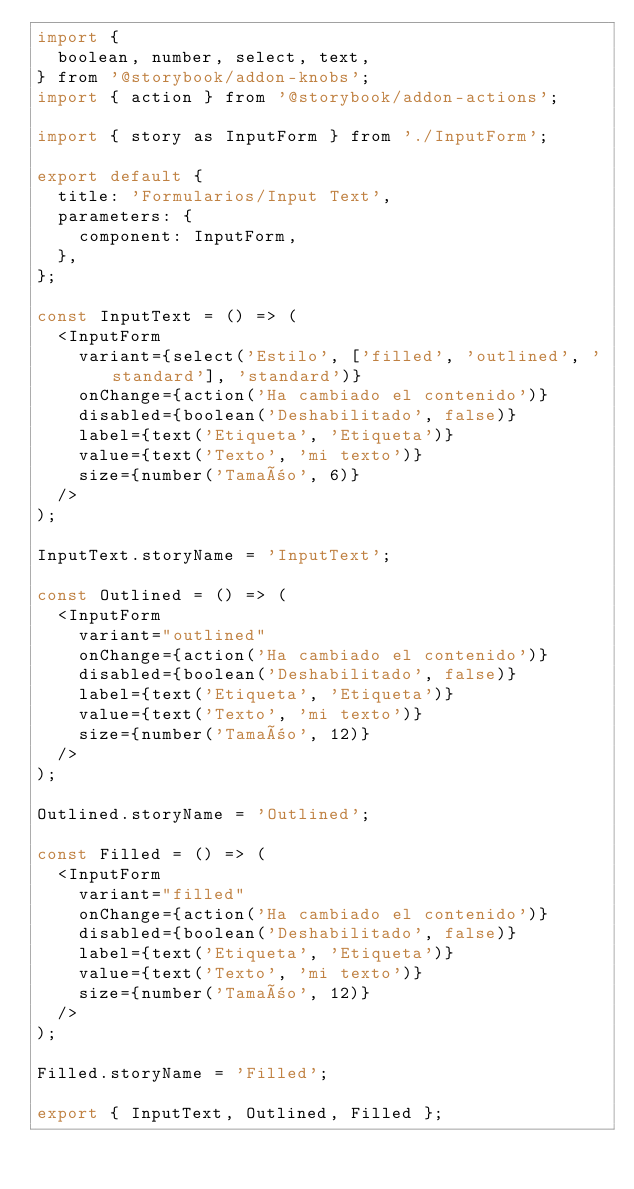Convert code to text. <code><loc_0><loc_0><loc_500><loc_500><_JavaScript_>import {
  boolean, number, select, text,
} from '@storybook/addon-knobs';
import { action } from '@storybook/addon-actions';

import { story as InputForm } from './InputForm';

export default {
  title: 'Formularios/Input Text',
  parameters: {
    component: InputForm,
  },
};

const InputText = () => (
  <InputForm
    variant={select('Estilo', ['filled', 'outlined', 'standard'], 'standard')}
    onChange={action('Ha cambiado el contenido')}
    disabled={boolean('Deshabilitado', false)}
    label={text('Etiqueta', 'Etiqueta')}
    value={text('Texto', 'mi texto')}
    size={number('Tamaño', 6)}
  />
);

InputText.storyName = 'InputText';

const Outlined = () => (
  <InputForm
    variant="outlined"
    onChange={action('Ha cambiado el contenido')}
    disabled={boolean('Deshabilitado', false)}
    label={text('Etiqueta', 'Etiqueta')}
    value={text('Texto', 'mi texto')}
    size={number('Tamaño', 12)}
  />
);

Outlined.storyName = 'Outlined';

const Filled = () => (
  <InputForm
    variant="filled"
    onChange={action('Ha cambiado el contenido')}
    disabled={boolean('Deshabilitado', false)}
    label={text('Etiqueta', 'Etiqueta')}
    value={text('Texto', 'mi texto')}
    size={number('Tamaño', 12)}
  />
);

Filled.storyName = 'Filled';

export { InputText, Outlined, Filled };
</code> 